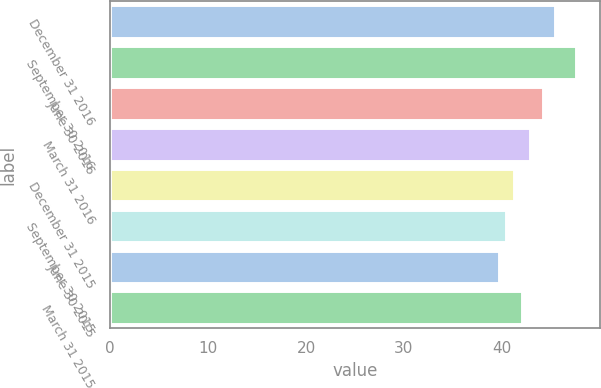Convert chart. <chart><loc_0><loc_0><loc_500><loc_500><bar_chart><fcel>December 31 2016<fcel>September 30 2016<fcel>June 30 2016<fcel>March 31 2016<fcel>December 31 2015<fcel>September 30 2015<fcel>June 30 2015<fcel>March 31 2015<nl><fcel>45.45<fcel>47.59<fcel>44.16<fcel>42.82<fcel>41.24<fcel>40.45<fcel>39.66<fcel>42.03<nl></chart> 